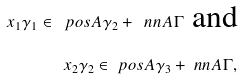<formula> <loc_0><loc_0><loc_500><loc_500>x _ { 1 } \gamma _ { 1 } \in \ p o s A \gamma _ { 2 } + \ n n A \Gamma \text { and} \\ x _ { 2 } \gamma _ { 2 } \in \ p o s A \gamma _ { 3 } + \ n n A \Gamma ,</formula> 